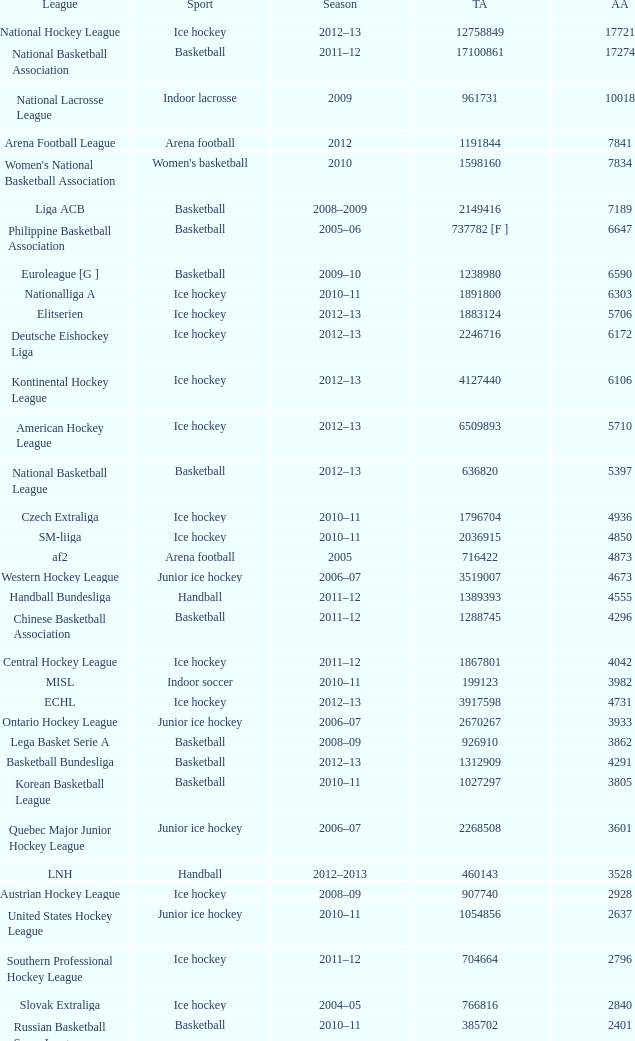What's the average attendance of the league with a total attendance of 2268508? 3601.0. 